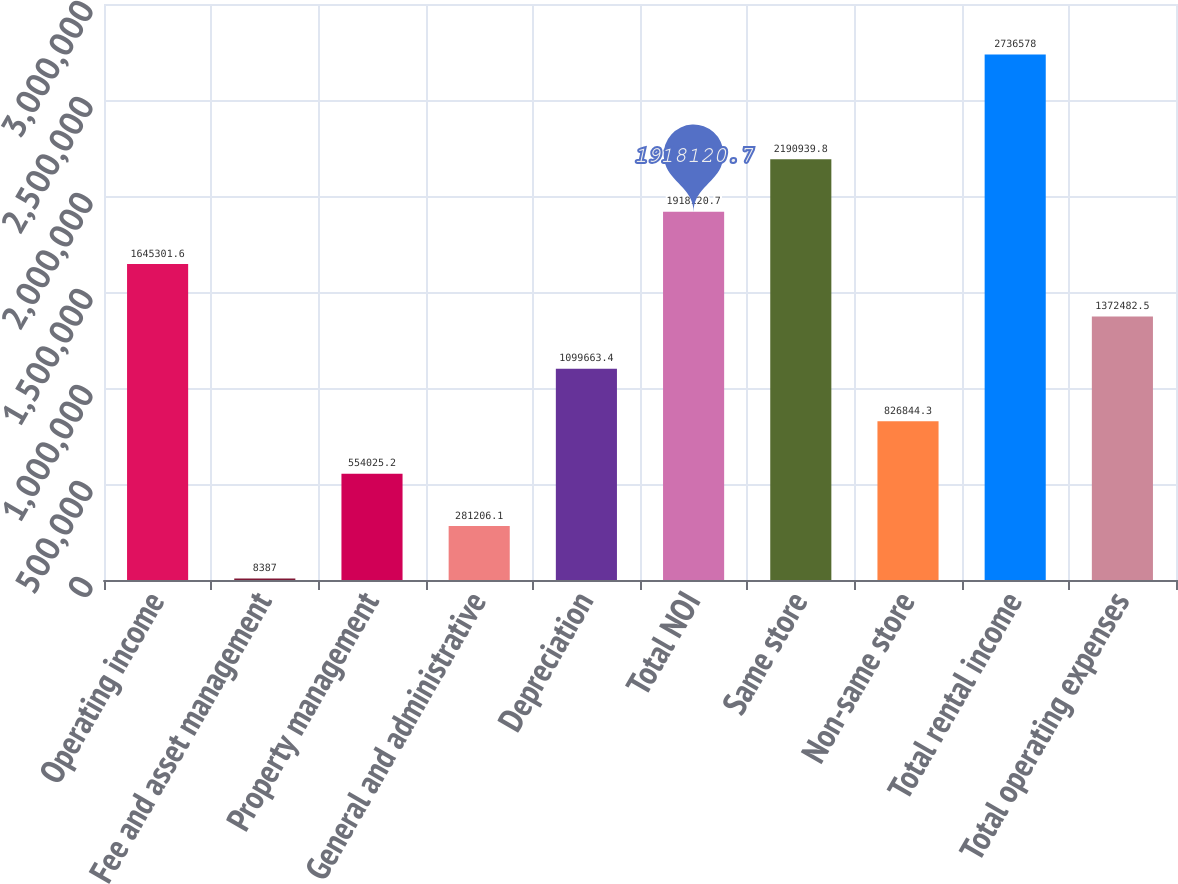<chart> <loc_0><loc_0><loc_500><loc_500><bar_chart><fcel>Operating income<fcel>Fee and asset management<fcel>Property management<fcel>General and administrative<fcel>Depreciation<fcel>Total NOI<fcel>Same store<fcel>Non-same store<fcel>Total rental income<fcel>Total operating expenses<nl><fcel>1.6453e+06<fcel>8387<fcel>554025<fcel>281206<fcel>1.09966e+06<fcel>1.91812e+06<fcel>2.19094e+06<fcel>826844<fcel>2.73658e+06<fcel>1.37248e+06<nl></chart> 